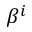<formula> <loc_0><loc_0><loc_500><loc_500>\beta ^ { i }</formula> 